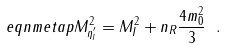Convert formula to latex. <formula><loc_0><loc_0><loc_500><loc_500>\ e q n { m e t a p } M ^ { 2 } _ { \eta ^ { \prime } _ { I } } = M ^ { 2 } _ { I } + n _ { R } \frac { 4 m _ { 0 } ^ { 2 } } { 3 } \ .</formula> 